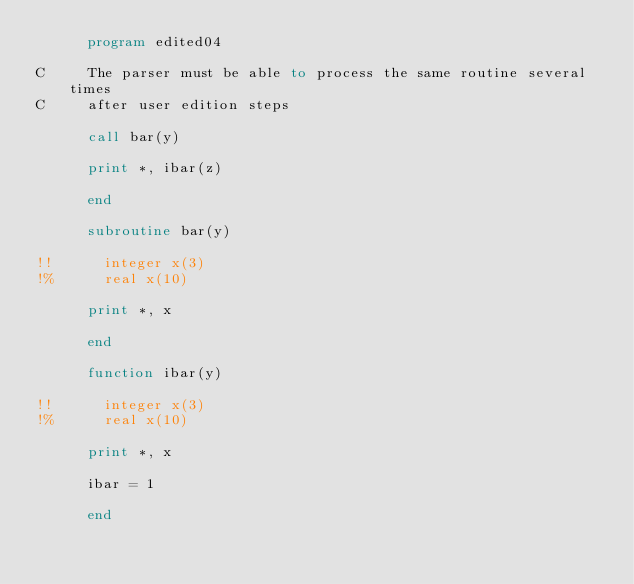Convert code to text. <code><loc_0><loc_0><loc_500><loc_500><_FORTRAN_>      program edited04

C     The parser must be able to process the same routine several times
C     after user edition steps

      call bar(y)

      print *, ibar(z)

      end

      subroutine bar(y)

!!      integer x(3)
!%      real x(10)

      print *, x

      end

      function ibar(y)

!!      integer x(3)
!%      real x(10)

      print *, x

      ibar = 1

      end
</code> 